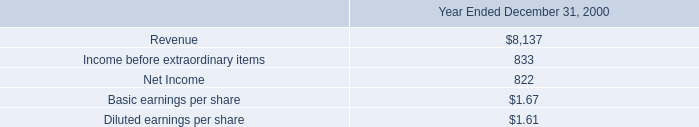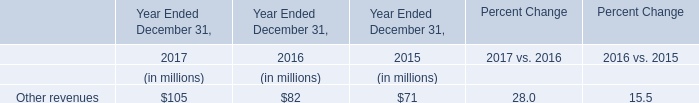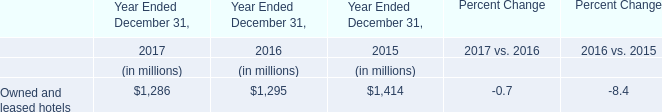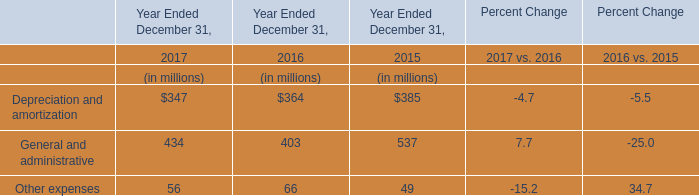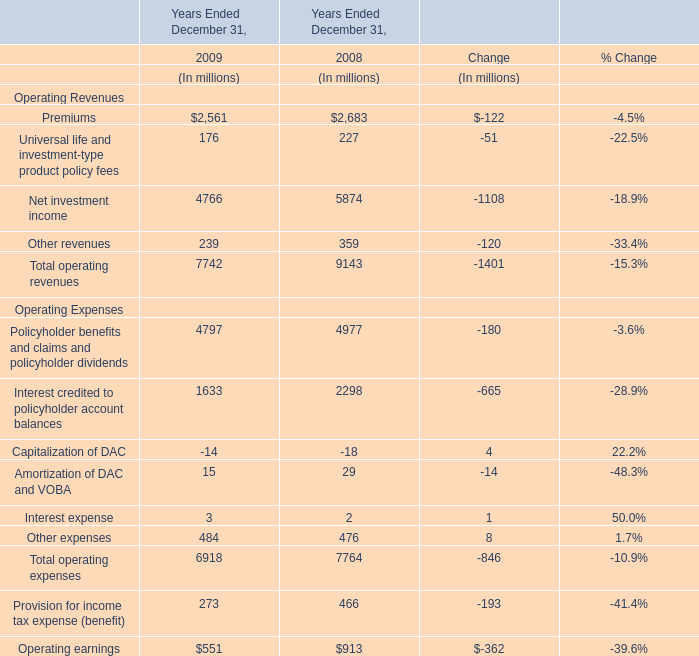disco losses improved by how much in 2001? 
Computations: ((58 - 31) * 1000000)
Answer: 27000000.0. 